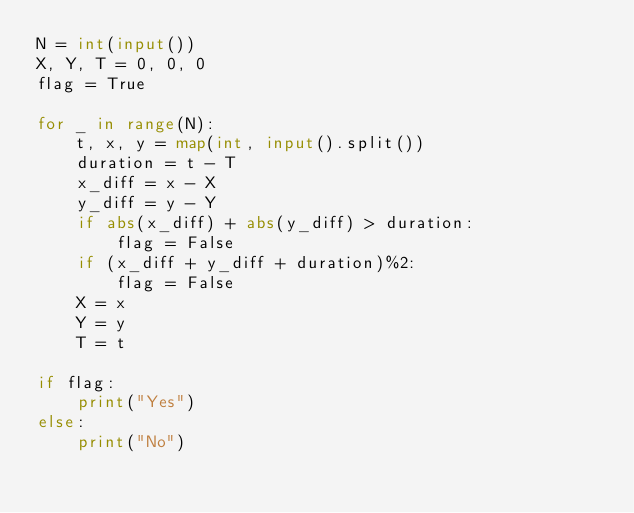<code> <loc_0><loc_0><loc_500><loc_500><_Python_>N = int(input())
X, Y, T = 0, 0, 0
flag = True

for _ in range(N):
    t, x, y = map(int, input().split())
    duration = t - T
    x_diff = x - X
    y_diff = y - Y
    if abs(x_diff) + abs(y_diff) > duration:
        flag = False
    if (x_diff + y_diff + duration)%2:
        flag = False
    X = x
    Y = y
    T = t
        
if flag:
    print("Yes")
else:
    print("No")</code> 